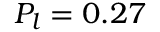Convert formula to latex. <formula><loc_0><loc_0><loc_500><loc_500>P _ { l } = 0 . 2 7</formula> 